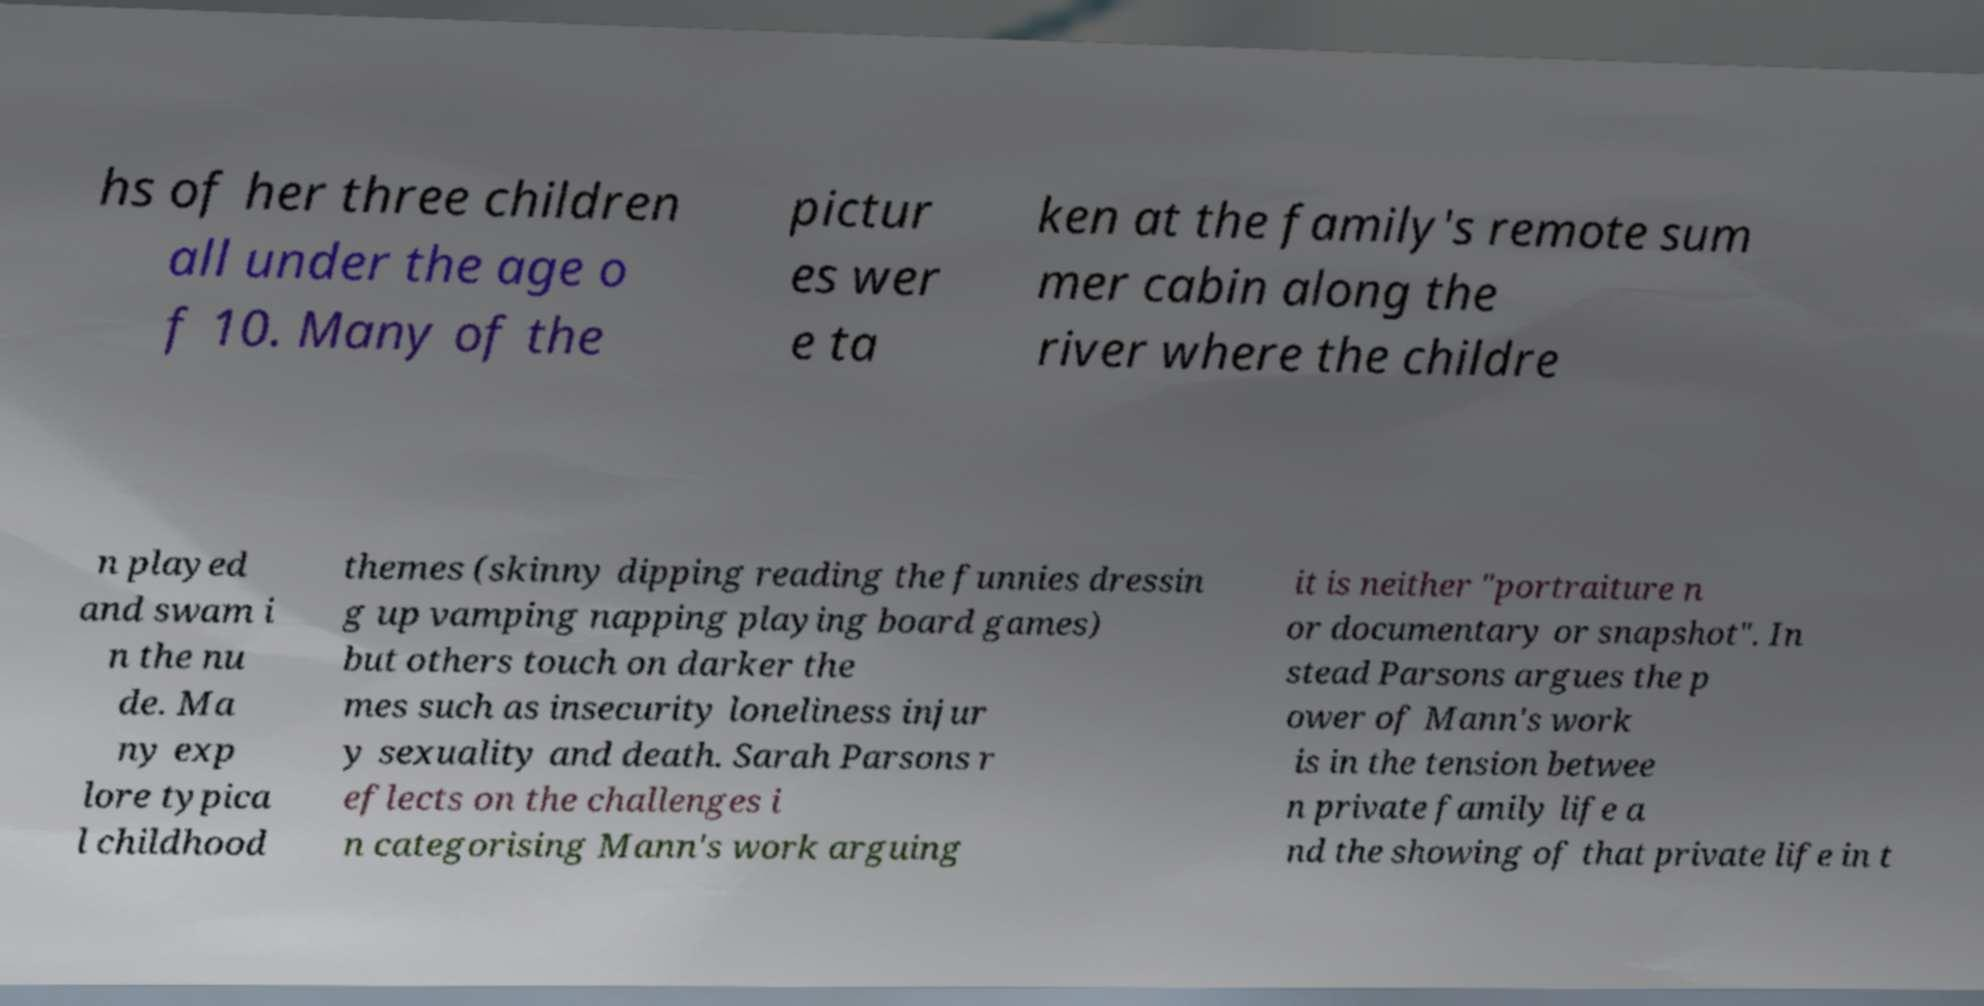Could you assist in decoding the text presented in this image and type it out clearly? hs of her three children all under the age o f 10. Many of the pictur es wer e ta ken at the family's remote sum mer cabin along the river where the childre n played and swam i n the nu de. Ma ny exp lore typica l childhood themes (skinny dipping reading the funnies dressin g up vamping napping playing board games) but others touch on darker the mes such as insecurity loneliness injur y sexuality and death. Sarah Parsons r eflects on the challenges i n categorising Mann's work arguing it is neither "portraiture n or documentary or snapshot". In stead Parsons argues the p ower of Mann's work is in the tension betwee n private family life a nd the showing of that private life in t 